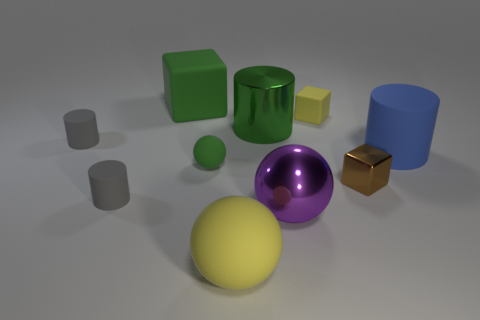Can you describe the sizes and colors of the objects in the image? Certainly! There are a variety of objects in the image, each with unique sizes and colors. We have a large yellow matte sphere and a purple glossy sphere of medium size. There are two cubes, one green, one bronze. The green cube is large and matte, while the bronze one is small and has a glossy texture. Additionally, there are two cylinders, one glossy green and one matte blue, and finally, there are two smaller grey objects, one cylinder and one cube, both with a matte finish. 